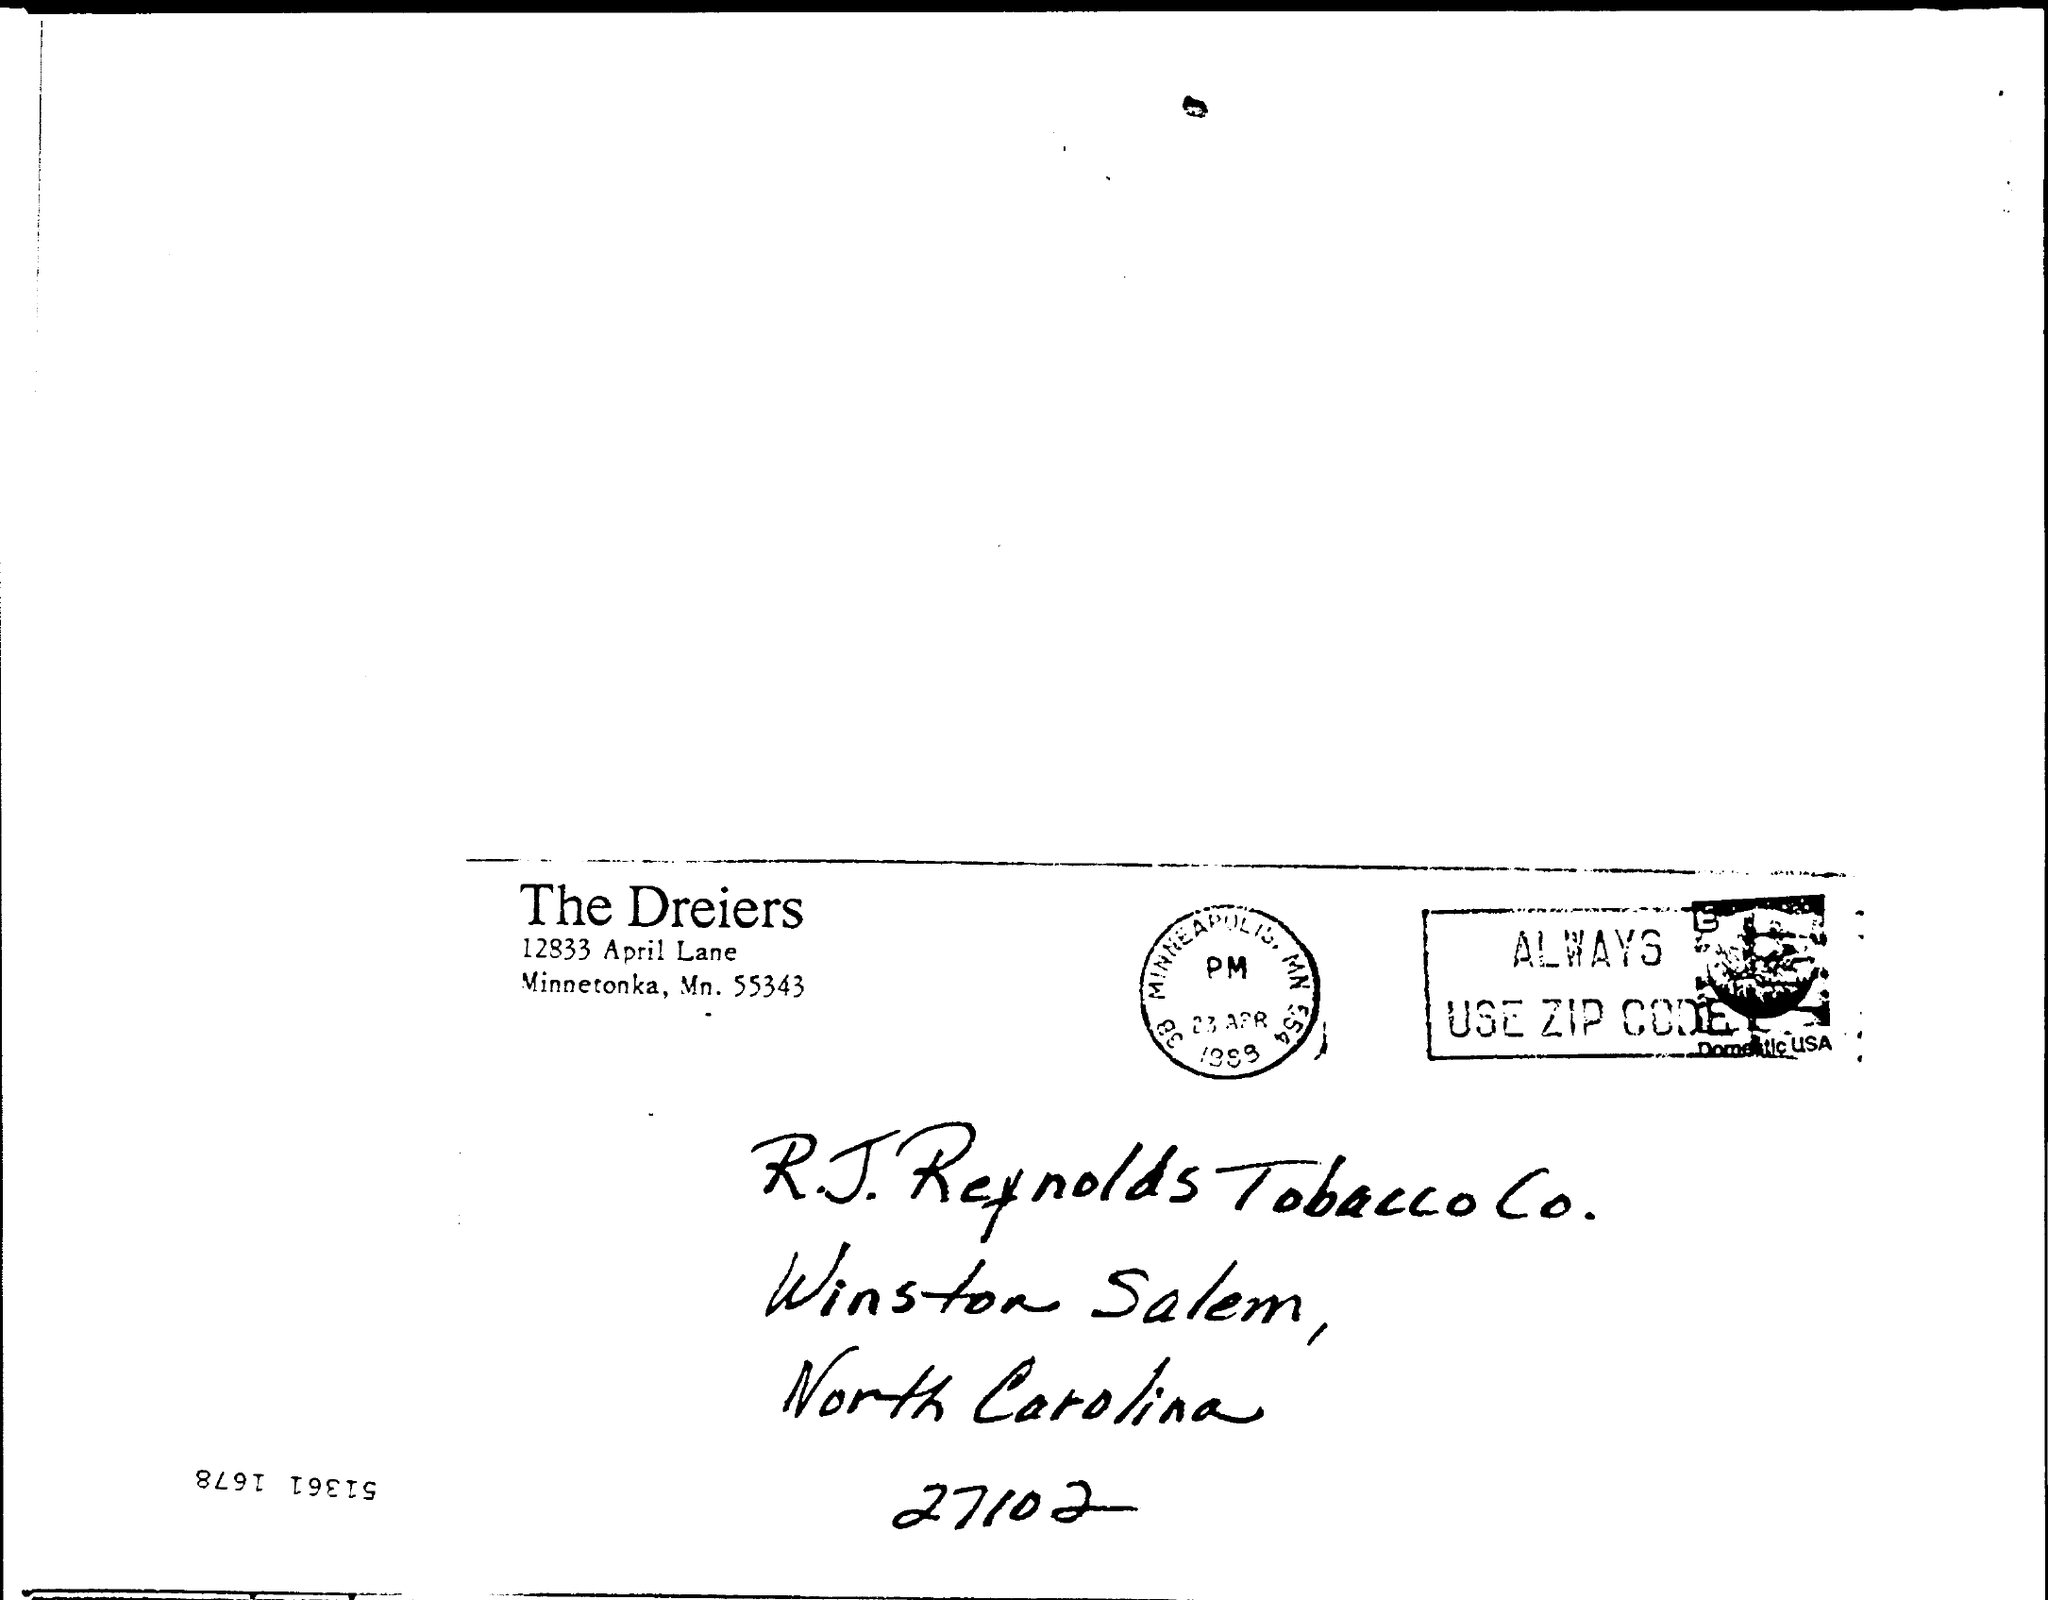Mention a couple of crucial points in this snapshot. The letter is from the Dreiers. The zip code for R. J. Reynolds Tobacco Co. is 27102. 